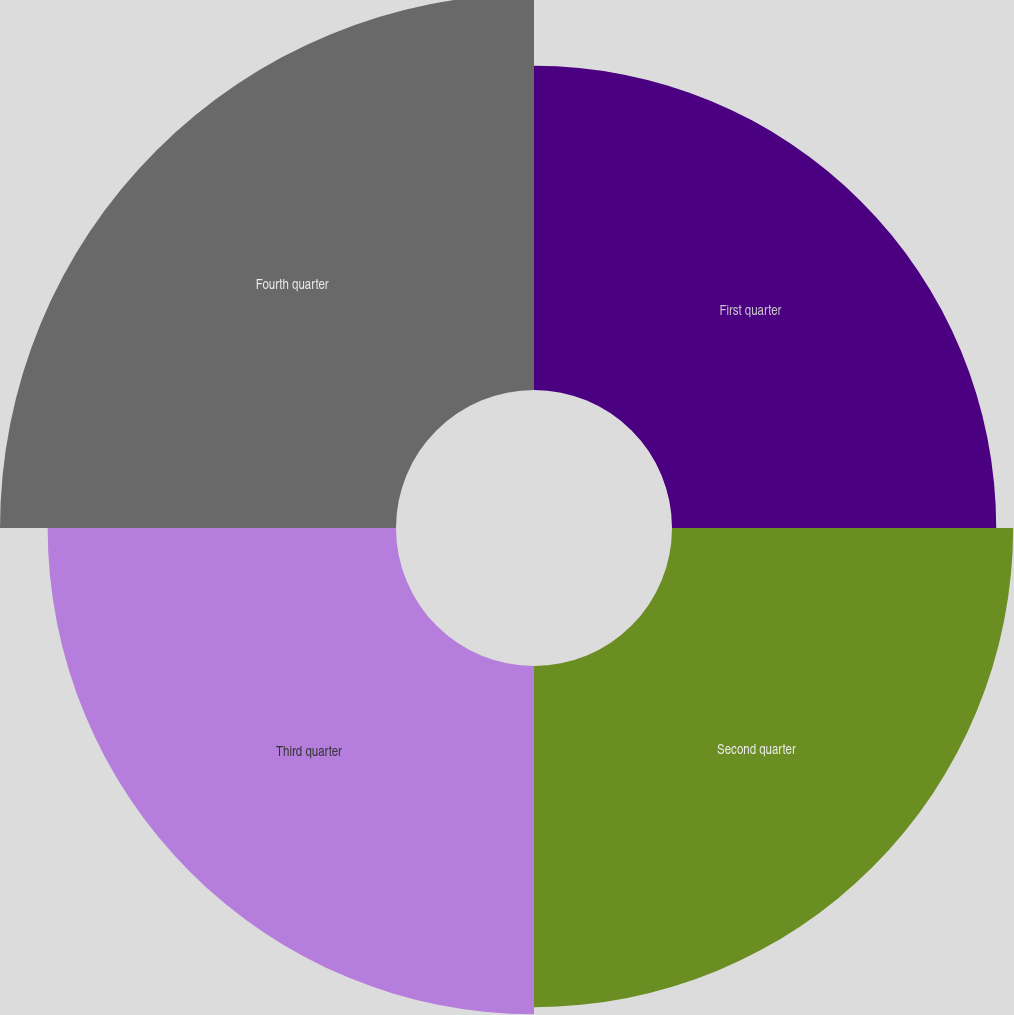Convert chart to OTSL. <chart><loc_0><loc_0><loc_500><loc_500><pie_chart><fcel>First quarter<fcel>Second quarter<fcel>Third quarter<fcel>Fourth quarter<nl><fcel>23.0%<fcel>24.2%<fcel>24.71%<fcel>28.09%<nl></chart> 